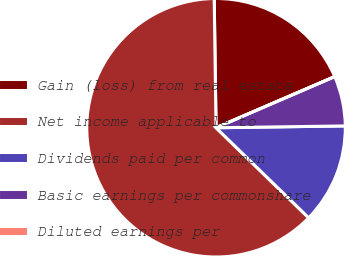<chart> <loc_0><loc_0><loc_500><loc_500><pie_chart><fcel>Gain (loss) from real estate<fcel>Net income applicable to<fcel>Dividends paid per common<fcel>Basic earnings per commonshare<fcel>Diluted earnings per<nl><fcel>18.75%<fcel>62.5%<fcel>12.5%<fcel>6.25%<fcel>0.0%<nl></chart> 